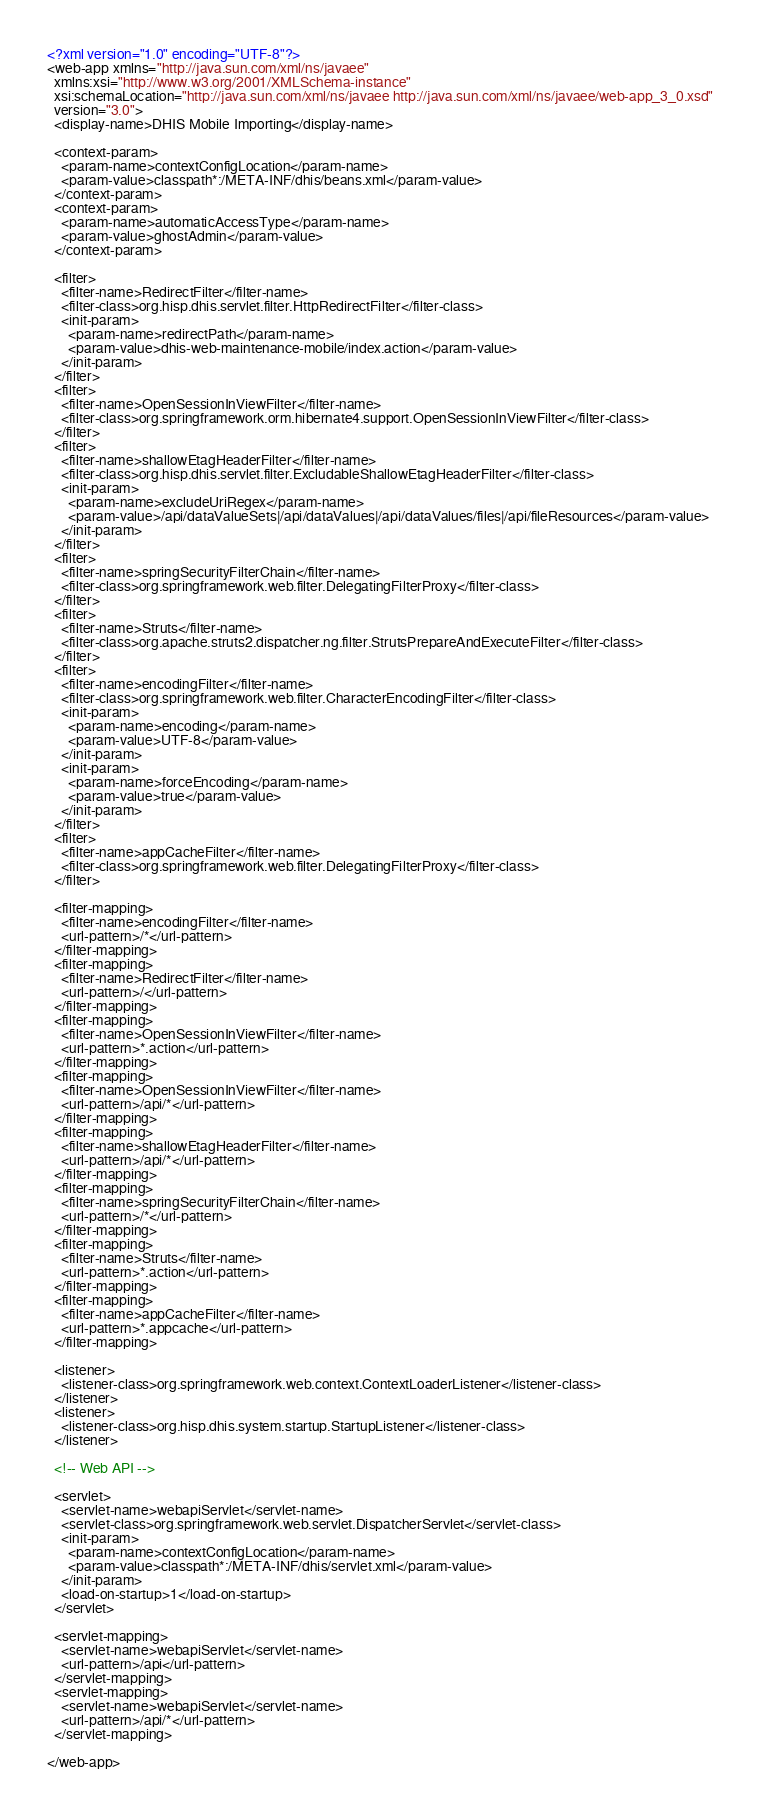Convert code to text. <code><loc_0><loc_0><loc_500><loc_500><_XML_><?xml version="1.0" encoding="UTF-8"?>
<web-app xmlns="http://java.sun.com/xml/ns/javaee"
  xmlns:xsi="http://www.w3.org/2001/XMLSchema-instance"
  xsi:schemaLocation="http://java.sun.com/xml/ns/javaee http://java.sun.com/xml/ns/javaee/web-app_3_0.xsd"
  version="3.0">
  <display-name>DHIS Mobile Importing</display-name>

  <context-param>
    <param-name>contextConfigLocation</param-name>
    <param-value>classpath*:/META-INF/dhis/beans.xml</param-value>
  </context-param>
  <context-param>
    <param-name>automaticAccessType</param-name>
    <param-value>ghostAdmin</param-value>
  </context-param>

  <filter>
    <filter-name>RedirectFilter</filter-name>
    <filter-class>org.hisp.dhis.servlet.filter.HttpRedirectFilter</filter-class>
    <init-param>
      <param-name>redirectPath</param-name>
      <param-value>dhis-web-maintenance-mobile/index.action</param-value>
    </init-param>
  </filter>
  <filter>
    <filter-name>OpenSessionInViewFilter</filter-name>
    <filter-class>org.springframework.orm.hibernate4.support.OpenSessionInViewFilter</filter-class>
  </filter>
  <filter>
    <filter-name>shallowEtagHeaderFilter</filter-name>
    <filter-class>org.hisp.dhis.servlet.filter.ExcludableShallowEtagHeaderFilter</filter-class>
    <init-param>
      <param-name>excludeUriRegex</param-name>
      <param-value>/api/dataValueSets|/api/dataValues|/api/dataValues/files|/api/fileResources</param-value>
    </init-param>
  </filter>
  <filter>
    <filter-name>springSecurityFilterChain</filter-name>
    <filter-class>org.springframework.web.filter.DelegatingFilterProxy</filter-class>
  </filter>
  <filter>
    <filter-name>Struts</filter-name>
    <filter-class>org.apache.struts2.dispatcher.ng.filter.StrutsPrepareAndExecuteFilter</filter-class>
  </filter>
  <filter>
    <filter-name>encodingFilter</filter-name>
    <filter-class>org.springframework.web.filter.CharacterEncodingFilter</filter-class>
    <init-param>
      <param-name>encoding</param-name>
      <param-value>UTF-8</param-value>
    </init-param>
    <init-param>
      <param-name>forceEncoding</param-name>
      <param-value>true</param-value>
    </init-param>
  </filter>
  <filter>
    <filter-name>appCacheFilter</filter-name>
    <filter-class>org.springframework.web.filter.DelegatingFilterProxy</filter-class>
  </filter>

  <filter-mapping>
    <filter-name>encodingFilter</filter-name>
    <url-pattern>/*</url-pattern>
  </filter-mapping>
  <filter-mapping>
    <filter-name>RedirectFilter</filter-name>
    <url-pattern>/</url-pattern>
  </filter-mapping>
  <filter-mapping>
    <filter-name>OpenSessionInViewFilter</filter-name>
    <url-pattern>*.action</url-pattern>
  </filter-mapping>
  <filter-mapping>
    <filter-name>OpenSessionInViewFilter</filter-name>
    <url-pattern>/api/*</url-pattern>
  </filter-mapping>
  <filter-mapping>
    <filter-name>shallowEtagHeaderFilter</filter-name>
    <url-pattern>/api/*</url-pattern>
  </filter-mapping>
  <filter-mapping>
    <filter-name>springSecurityFilterChain</filter-name>
    <url-pattern>/*</url-pattern>
  </filter-mapping>
  <filter-mapping>
    <filter-name>Struts</filter-name>
    <url-pattern>*.action</url-pattern>
  </filter-mapping>
  <filter-mapping>
    <filter-name>appCacheFilter</filter-name>
    <url-pattern>*.appcache</url-pattern>
  </filter-mapping>

  <listener>
    <listener-class>org.springframework.web.context.ContextLoaderListener</listener-class>
  </listener>
  <listener>
    <listener-class>org.hisp.dhis.system.startup.StartupListener</listener-class>
  </listener>

  <!-- Web API -->

  <servlet>
    <servlet-name>webapiServlet</servlet-name>
    <servlet-class>org.springframework.web.servlet.DispatcherServlet</servlet-class>
    <init-param>
      <param-name>contextConfigLocation</param-name>
      <param-value>classpath*:/META-INF/dhis/servlet.xml</param-value>
    </init-param>
    <load-on-startup>1</load-on-startup>
  </servlet>

  <servlet-mapping>
    <servlet-name>webapiServlet</servlet-name>
    <url-pattern>/api</url-pattern>
  </servlet-mapping>
  <servlet-mapping>
    <servlet-name>webapiServlet</servlet-name>
    <url-pattern>/api/*</url-pattern>
  </servlet-mapping>

</web-app>
</code> 